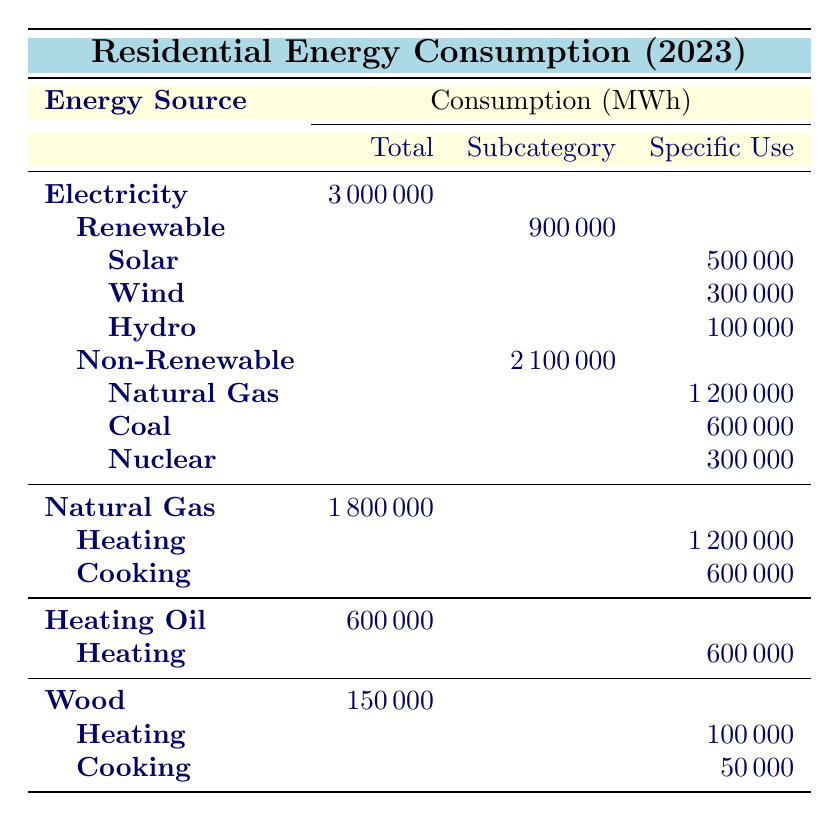What is the total residential energy consumption from electricity? The table indicates that the total consumption from electricity is listed as 3,000,000 MWh.
Answer: 3,000,000 MWh How much electricity comes from renewable sources? The breakdown shows that renewable sources contribute a total of 900,000 MWh to the electricity consumption.
Answer: 900,000 MWh What is the combined total consumption of Natural Gas for heating and cooking? The total consumption of Natural Gas for heating is 1,200,000 MWh and for cooking is 600,000 MWh. Adding these values gives 1,200,000 + 600,000 = 1,800,000 MWh.
Answer: 1,800,000 MWh Is the total consumption of heating oil greater than that of wood? The table shows that heating oil has a total consumption of 600,000 MWh, while wood has 150,000 MWh. Since 600,000 is greater than 150,000, the statement is true.
Answer: Yes What percentage of the total residential energy consumption comes from solar energy? To find the percentage, first identify that the total residential energy consumption is 4,800,000 MWh (3,000,000 from electricity and 1,800,000 from Natural Gas, 600,000 from heating oil, and 150,000 from wood). Solar energy consumption is 500,000 MWh. The percentage is (500,000 / 4,800,000) * 100 ≈ 10.42%.
Answer: Approximately 10.42% How much energy is consumed in heating from all sources combined? The total for heating involves adding all the heating contributions: from Natural Gas (1,200,000 MWh), Heating Oil (600,000 MWh), and Wood (100,000 MWh). So, 1,200,000 + 600,000 + 100,000 = 1,900,000 MWh for heating.
Answer: 1,900,000 MWh Is the consumption of coal greater than the consumption of nuclear energy? The table lists coal consumption as 600,000 MWh and nuclear energy as 300,000 MWh. Since 600,000 is greater than 300,000, the statement is true.
Answer: Yes What is the total non-renewable energy consumption in residential areas? The non-renewable energy consumption consists of Natural Gas (1,200,000 MWh), Coal (600,000 MWh), and Nuclear (300,000 MWh). Summing these gives 1,200,000 + 600,000 + 300,000 = 2,100,000 MWh.
Answer: 2,100,000 MWh 